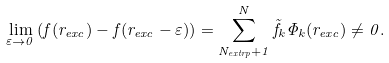<formula> <loc_0><loc_0><loc_500><loc_500>\lim _ { \varepsilon \to 0 } \left ( f ( r _ { e x c } ) - f ( r _ { e x c } - \varepsilon ) \right ) = \sum _ { N _ { e x t r p } + 1 } ^ { N } \tilde { f } _ { k } \Phi _ { k } ( r _ { e x c } ) \neq 0 .</formula> 